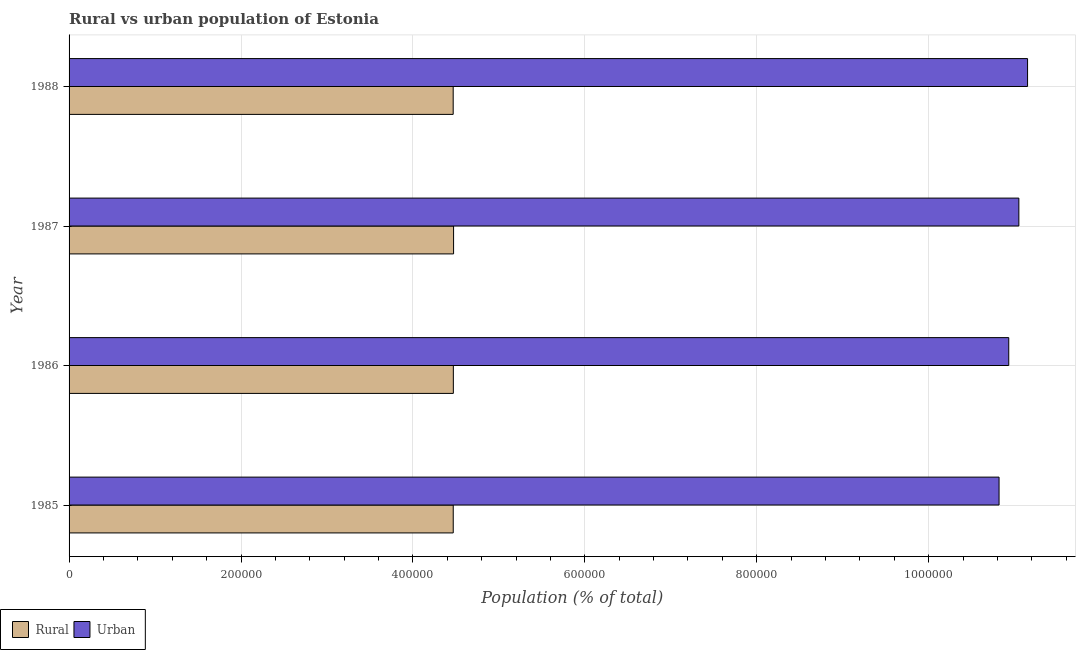How many groups of bars are there?
Offer a terse response. 4. Are the number of bars per tick equal to the number of legend labels?
Provide a short and direct response. Yes. Are the number of bars on each tick of the Y-axis equal?
Your answer should be very brief. Yes. How many bars are there on the 1st tick from the bottom?
Provide a succinct answer. 2. What is the rural population density in 1988?
Offer a terse response. 4.47e+05. Across all years, what is the maximum rural population density?
Make the answer very short. 4.47e+05. Across all years, what is the minimum urban population density?
Your answer should be very brief. 1.08e+06. In which year was the rural population density maximum?
Offer a terse response. 1987. What is the total urban population density in the graph?
Offer a terse response. 4.39e+06. What is the difference between the rural population density in 1985 and that in 1986?
Ensure brevity in your answer.  -131. What is the difference between the rural population density in 1987 and the urban population density in 1988?
Your answer should be compact. -6.68e+05. What is the average urban population density per year?
Offer a very short reply. 1.10e+06. In the year 1988, what is the difference between the rural population density and urban population density?
Your response must be concise. -6.68e+05. In how many years, is the rural population density greater than 1000000 %?
Make the answer very short. 0. What is the difference between the highest and the second highest rural population density?
Offer a very short reply. 264. What is the difference between the highest and the lowest urban population density?
Keep it short and to the point. 3.32e+04. In how many years, is the rural population density greater than the average rural population density taken over all years?
Your response must be concise. 2. Is the sum of the rural population density in 1986 and 1987 greater than the maximum urban population density across all years?
Make the answer very short. No. What does the 2nd bar from the top in 1987 represents?
Keep it short and to the point. Rural. What does the 2nd bar from the bottom in 1985 represents?
Your answer should be very brief. Urban. How many years are there in the graph?
Provide a succinct answer. 4. Are the values on the major ticks of X-axis written in scientific E-notation?
Ensure brevity in your answer.  No. Where does the legend appear in the graph?
Provide a succinct answer. Bottom left. How many legend labels are there?
Make the answer very short. 2. What is the title of the graph?
Provide a short and direct response. Rural vs urban population of Estonia. What is the label or title of the X-axis?
Keep it short and to the point. Population (% of total). What is the Population (% of total) in Rural in 1985?
Your answer should be compact. 4.47e+05. What is the Population (% of total) of Urban in 1985?
Make the answer very short. 1.08e+06. What is the Population (% of total) in Rural in 1986?
Keep it short and to the point. 4.47e+05. What is the Population (% of total) of Urban in 1986?
Offer a terse response. 1.09e+06. What is the Population (% of total) in Rural in 1987?
Keep it short and to the point. 4.47e+05. What is the Population (% of total) in Urban in 1987?
Give a very brief answer. 1.10e+06. What is the Population (% of total) of Rural in 1988?
Your answer should be very brief. 4.47e+05. What is the Population (% of total) of Urban in 1988?
Give a very brief answer. 1.12e+06. Across all years, what is the maximum Population (% of total) in Rural?
Your answer should be very brief. 4.47e+05. Across all years, what is the maximum Population (% of total) of Urban?
Your response must be concise. 1.12e+06. Across all years, what is the minimum Population (% of total) in Rural?
Keep it short and to the point. 4.47e+05. Across all years, what is the minimum Population (% of total) in Urban?
Your answer should be very brief. 1.08e+06. What is the total Population (% of total) in Rural in the graph?
Make the answer very short. 1.79e+06. What is the total Population (% of total) of Urban in the graph?
Offer a terse response. 4.39e+06. What is the difference between the Population (% of total) in Rural in 1985 and that in 1986?
Make the answer very short. -131. What is the difference between the Population (% of total) of Urban in 1985 and that in 1986?
Your response must be concise. -1.13e+04. What is the difference between the Population (% of total) of Rural in 1985 and that in 1987?
Provide a short and direct response. -395. What is the difference between the Population (% of total) in Urban in 1985 and that in 1987?
Make the answer very short. -2.30e+04. What is the difference between the Population (% of total) of Urban in 1985 and that in 1988?
Give a very brief answer. -3.32e+04. What is the difference between the Population (% of total) in Rural in 1986 and that in 1987?
Provide a short and direct response. -264. What is the difference between the Population (% of total) of Urban in 1986 and that in 1987?
Your answer should be compact. -1.18e+04. What is the difference between the Population (% of total) of Rural in 1986 and that in 1988?
Give a very brief answer. 180. What is the difference between the Population (% of total) in Urban in 1986 and that in 1988?
Keep it short and to the point. -2.19e+04. What is the difference between the Population (% of total) in Rural in 1987 and that in 1988?
Give a very brief answer. 444. What is the difference between the Population (% of total) of Urban in 1987 and that in 1988?
Make the answer very short. -1.01e+04. What is the difference between the Population (% of total) of Rural in 1985 and the Population (% of total) of Urban in 1986?
Offer a terse response. -6.46e+05. What is the difference between the Population (% of total) in Rural in 1985 and the Population (% of total) in Urban in 1987?
Your answer should be compact. -6.58e+05. What is the difference between the Population (% of total) of Rural in 1985 and the Population (% of total) of Urban in 1988?
Give a very brief answer. -6.68e+05. What is the difference between the Population (% of total) in Rural in 1986 and the Population (% of total) in Urban in 1987?
Your answer should be very brief. -6.58e+05. What is the difference between the Population (% of total) of Rural in 1986 and the Population (% of total) of Urban in 1988?
Offer a very short reply. -6.68e+05. What is the difference between the Population (% of total) of Rural in 1987 and the Population (% of total) of Urban in 1988?
Give a very brief answer. -6.68e+05. What is the average Population (% of total) in Rural per year?
Your response must be concise. 4.47e+05. What is the average Population (% of total) in Urban per year?
Ensure brevity in your answer.  1.10e+06. In the year 1985, what is the difference between the Population (% of total) of Rural and Population (% of total) of Urban?
Provide a short and direct response. -6.35e+05. In the year 1986, what is the difference between the Population (% of total) of Rural and Population (% of total) of Urban?
Provide a short and direct response. -6.46e+05. In the year 1987, what is the difference between the Population (% of total) of Rural and Population (% of total) of Urban?
Offer a terse response. -6.58e+05. In the year 1988, what is the difference between the Population (% of total) of Rural and Population (% of total) of Urban?
Give a very brief answer. -6.68e+05. What is the ratio of the Population (% of total) of Rural in 1985 to that in 1986?
Your response must be concise. 1. What is the ratio of the Population (% of total) in Urban in 1985 to that in 1986?
Offer a terse response. 0.99. What is the ratio of the Population (% of total) of Rural in 1985 to that in 1987?
Your answer should be compact. 1. What is the ratio of the Population (% of total) of Urban in 1985 to that in 1987?
Offer a very short reply. 0.98. What is the ratio of the Population (% of total) in Rural in 1985 to that in 1988?
Offer a terse response. 1. What is the ratio of the Population (% of total) of Urban in 1985 to that in 1988?
Offer a terse response. 0.97. What is the ratio of the Population (% of total) in Rural in 1986 to that in 1987?
Ensure brevity in your answer.  1. What is the ratio of the Population (% of total) in Urban in 1986 to that in 1987?
Provide a succinct answer. 0.99. What is the ratio of the Population (% of total) in Urban in 1986 to that in 1988?
Make the answer very short. 0.98. What is the ratio of the Population (% of total) in Rural in 1987 to that in 1988?
Provide a short and direct response. 1. What is the ratio of the Population (% of total) in Urban in 1987 to that in 1988?
Offer a terse response. 0.99. What is the difference between the highest and the second highest Population (% of total) of Rural?
Ensure brevity in your answer.  264. What is the difference between the highest and the second highest Population (% of total) of Urban?
Give a very brief answer. 1.01e+04. What is the difference between the highest and the lowest Population (% of total) of Rural?
Your answer should be compact. 444. What is the difference between the highest and the lowest Population (% of total) of Urban?
Give a very brief answer. 3.32e+04. 